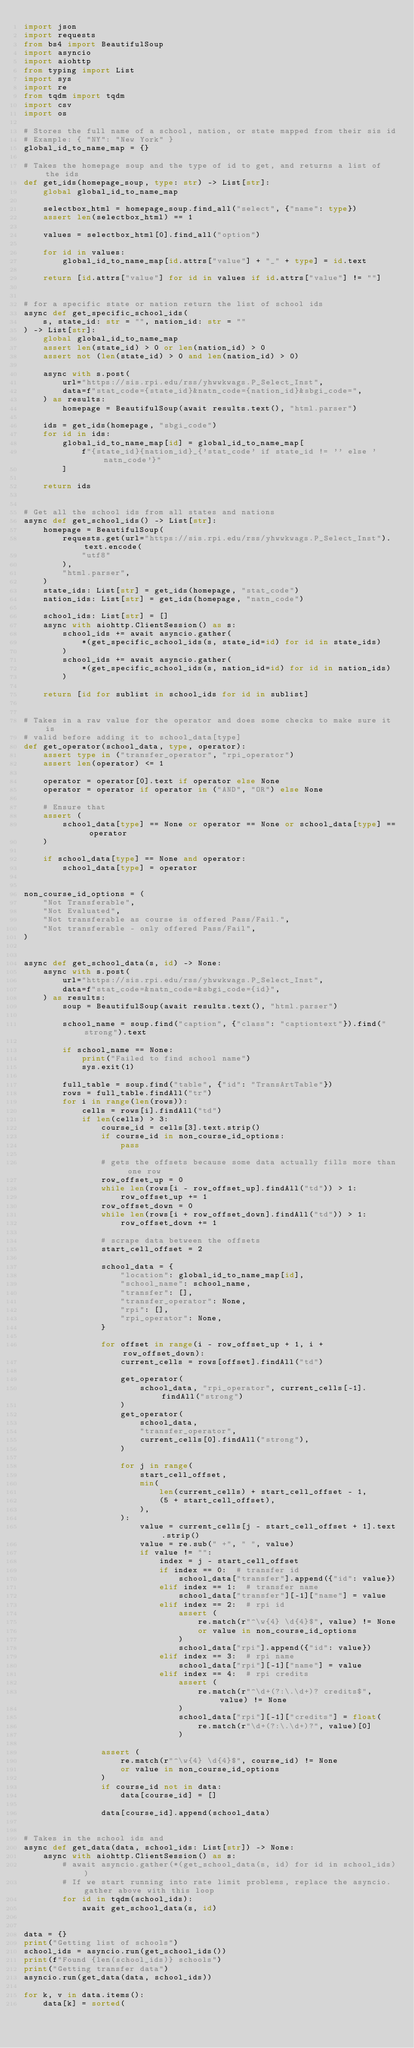Convert code to text. <code><loc_0><loc_0><loc_500><loc_500><_Python_>import json
import requests
from bs4 import BeautifulSoup
import asyncio
import aiohttp
from typing import List
import sys
import re
from tqdm import tqdm
import csv
import os

# Stores the full name of a school, nation, or state mapped from their sis id
# Example: { "NY": "New York" }
global_id_to_name_map = {}

# Takes the homepage soup and the type of id to get, and returns a list of the ids
def get_ids(homepage_soup, type: str) -> List[str]:
    global global_id_to_name_map

    selectbox_html = homepage_soup.find_all("select", {"name": type})
    assert len(selectbox_html) == 1

    values = selectbox_html[0].find_all("option")

    for id in values:
        global_id_to_name_map[id.attrs["value"] + "_" + type] = id.text

    return [id.attrs["value"] for id in values if id.attrs["value"] != ""]


# for a specific state or nation return the list of school ids
async def get_specific_school_ids(
    s, state_id: str = "", nation_id: str = ""
) -> List[str]:
    global global_id_to_name_map
    assert len(state_id) > 0 or len(nation_id) > 0
    assert not (len(state_id) > 0 and len(nation_id) > 0)

    async with s.post(
        url="https://sis.rpi.edu/rss/yhwwkwags.P_Select_Inst",
        data=f"stat_code={state_id}&natn_code={nation_id}&sbgi_code=",
    ) as results:
        homepage = BeautifulSoup(await results.text(), "html.parser")

    ids = get_ids(homepage, "sbgi_code")
    for id in ids:
        global_id_to_name_map[id] = global_id_to_name_map[
            f"{state_id}{nation_id}_{'stat_code' if state_id != '' else 'natn_code'}"
        ]

    return ids


# Get all the school ids from all states and nations
async def get_school_ids() -> List[str]:
    homepage = BeautifulSoup(
        requests.get(url="https://sis.rpi.edu/rss/yhwwkwags.P_Select_Inst").text.encode(
            "utf8"
        ),
        "html.parser",
    )
    state_ids: List[str] = get_ids(homepage, "stat_code")
    nation_ids: List[str] = get_ids(homepage, "natn_code")

    school_ids: List[str] = []
    async with aiohttp.ClientSession() as s:
        school_ids += await asyncio.gather(
            *(get_specific_school_ids(s, state_id=id) for id in state_ids)
        )
        school_ids += await asyncio.gather(
            *(get_specific_school_ids(s, nation_id=id) for id in nation_ids)
        )

    return [id for sublist in school_ids for id in sublist]


# Takes in a raw value for the operator and does some checks to make sure it is
# valid before adding it to school_data[type]
def get_operator(school_data, type, operator):
    assert type in ("transfer_operator", "rpi_operator")
    assert len(operator) <= 1

    operator = operator[0].text if operator else None
    operator = operator if operator in ("AND", "OR") else None

    # Ensure that
    assert (
        school_data[type] == None or operator == None or school_data[type] == operator
    )

    if school_data[type] == None and operator:
        school_data[type] = operator


non_course_id_options = (
    "Not Transferable",
    "Not Evaluated",
    "Not transferable as course is offered Pass/Fail.",
    "Not transferable - only offered Pass/Fail",
)


async def get_school_data(s, id) -> None:
    async with s.post(
        url="https://sis.rpi.edu/rss/yhwwkwags.P_Select_Inst",
        data=f"stat_code=&natn_code=&sbgi_code={id}",
    ) as results:
        soup = BeautifulSoup(await results.text(), "html.parser")

        school_name = soup.find("caption", {"class": "captiontext"}).find("strong").text

        if school_name == None:
            print("Failed to find school name")
            sys.exit(1)

        full_table = soup.find("table", {"id": "TransArtTable"})
        rows = full_table.findAll("tr")
        for i in range(len(rows)):
            cells = rows[i].findAll("td")
            if len(cells) > 3:
                course_id = cells[3].text.strip()
                if course_id in non_course_id_options:
                    pass

                # gets the offsets because some data actually fills more than one row
                row_offset_up = 0
                while len(rows[i - row_offset_up].findAll("td")) > 1:
                    row_offset_up += 1
                row_offset_down = 0
                while len(rows[i + row_offset_down].findAll("td")) > 1:
                    row_offset_down += 1

                # scrape data between the offsets
                start_cell_offset = 2

                school_data = {
                    "location": global_id_to_name_map[id],
                    "school_name": school_name,
                    "transfer": [],
                    "transfer_operator": None,
                    "rpi": [],
                    "rpi_operator": None,
                }

                for offset in range(i - row_offset_up + 1, i + row_offset_down):
                    current_cells = rows[offset].findAll("td")

                    get_operator(
                        school_data, "rpi_operator", current_cells[-1].findAll("strong")
                    )
                    get_operator(
                        school_data,
                        "transfer_operator",
                        current_cells[0].findAll("strong"),
                    )

                    for j in range(
                        start_cell_offset,
                        min(
                            len(current_cells) + start_cell_offset - 1,
                            (5 + start_cell_offset),
                        ),
                    ):
                        value = current_cells[j - start_cell_offset + 1].text.strip()
                        value = re.sub(" +", " ", value)
                        if value != "":
                            index = j - start_cell_offset
                            if index == 0:  # transfer id
                                school_data["transfer"].append({"id": value})
                            elif index == 1:  # transfer name
                                school_data["transfer"][-1]["name"] = value
                            elif index == 2:  # rpi id
                                assert (
                                    re.match(r"^\w{4} \d{4}$", value) != None
                                    or value in non_course_id_options
                                )
                                school_data["rpi"].append({"id": value})
                            elif index == 3:  # rpi name
                                school_data["rpi"][-1]["name"] = value
                            elif index == 4:  # rpi credits
                                assert (
                                    re.match(r"^\d+(?:\.\d+)? credits$", value) != None
                                )
                                school_data["rpi"][-1]["credits"] = float(
                                    re.match(r"\d+(?:\.\d+)?", value)[0]
                                )

                assert (
                    re.match(r"^\w{4} \d{4}$", course_id) != None
                    or value in non_course_id_options
                )
                if course_id not in data:
                    data[course_id] = []

                data[course_id].append(school_data)


# Takes in the school ids and
async def get_data(data, school_ids: List[str]) -> None:
    async with aiohttp.ClientSession() as s:
        # await asyncio.gather(*(get_school_data(s, id) for id in school_ids))
        # If we start running into rate limit problems, replace the asyncio.gather above with this loop
        for id in tqdm(school_ids):
            await get_school_data(s, id)


data = {}
print("Getting list of schools")
school_ids = asyncio.run(get_school_ids())
print(f"Found {len(school_ids)} schools")
print("Getting transfer data")
asyncio.run(get_data(data, school_ids))

for k, v in data.items():
    data[k] = sorted(</code> 